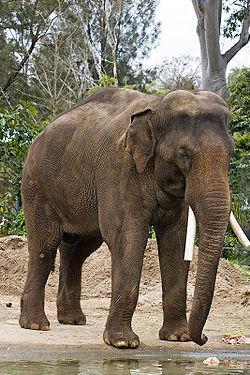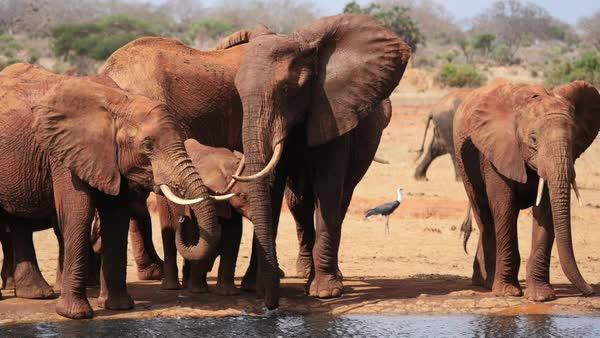The first image is the image on the left, the second image is the image on the right. For the images shown, is this caption "Both images contain an elephant with tusks." true? Answer yes or no. Yes. The first image is the image on the left, the second image is the image on the right. Analyze the images presented: Is the assertion "There are two elephants fully visible in the picture on the right" valid? Answer yes or no. No. 